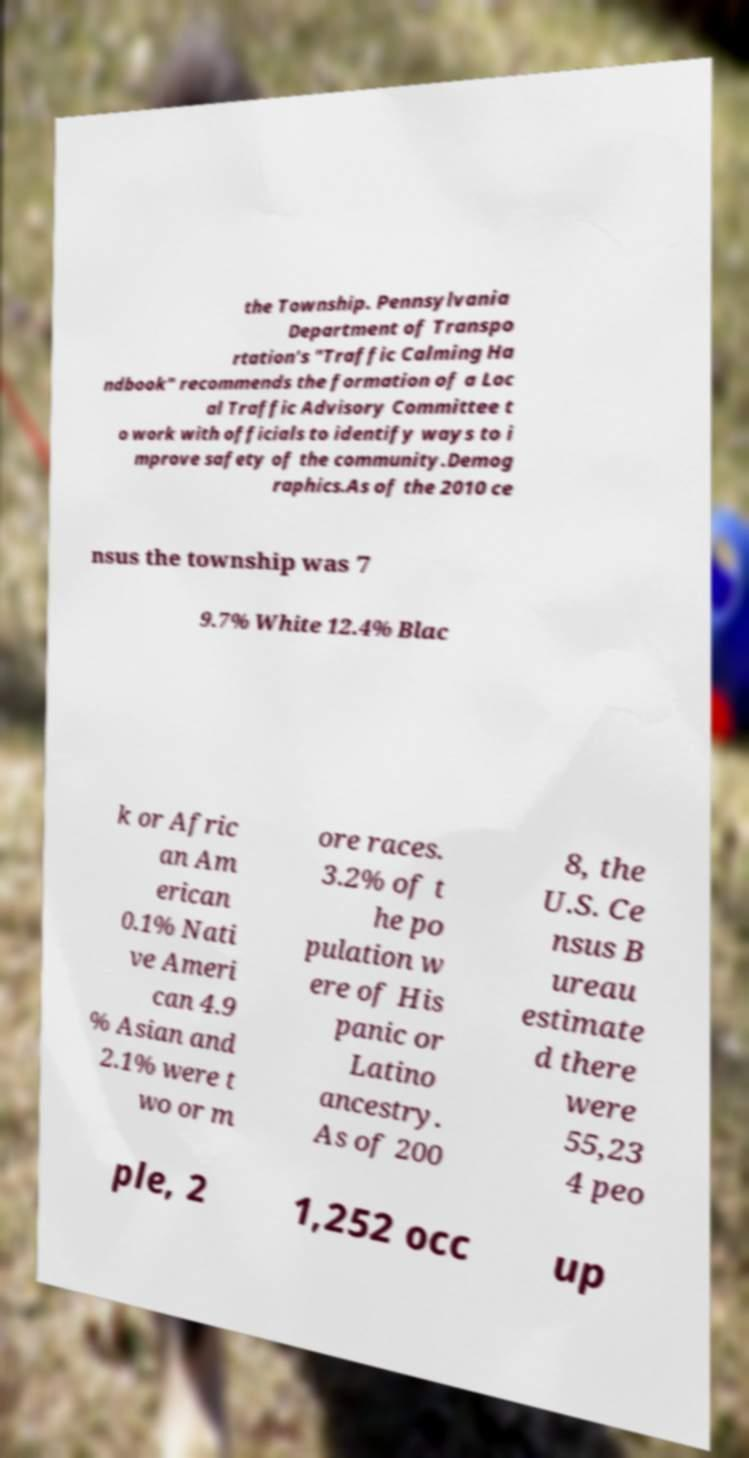Could you assist in decoding the text presented in this image and type it out clearly? the Township. Pennsylvania Department of Transpo rtation's "Traffic Calming Ha ndbook" recommends the formation of a Loc al Traffic Advisory Committee t o work with officials to identify ways to i mprove safety of the community.Demog raphics.As of the 2010 ce nsus the township was 7 9.7% White 12.4% Blac k or Afric an Am erican 0.1% Nati ve Ameri can 4.9 % Asian and 2.1% were t wo or m ore races. 3.2% of t he po pulation w ere of His panic or Latino ancestry. As of 200 8, the U.S. Ce nsus B ureau estimate d there were 55,23 4 peo ple, 2 1,252 occ up 